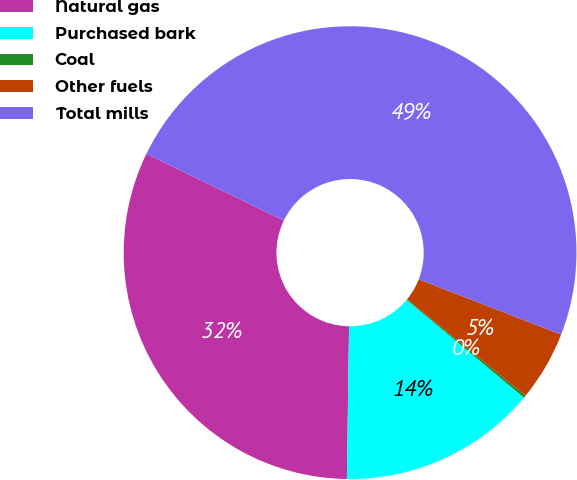<chart> <loc_0><loc_0><loc_500><loc_500><pie_chart><fcel>Natural gas<fcel>Purchased bark<fcel>Coal<fcel>Other fuels<fcel>Total mills<nl><fcel>31.97%<fcel>14.16%<fcel>0.17%<fcel>5.0%<fcel>48.71%<nl></chart> 